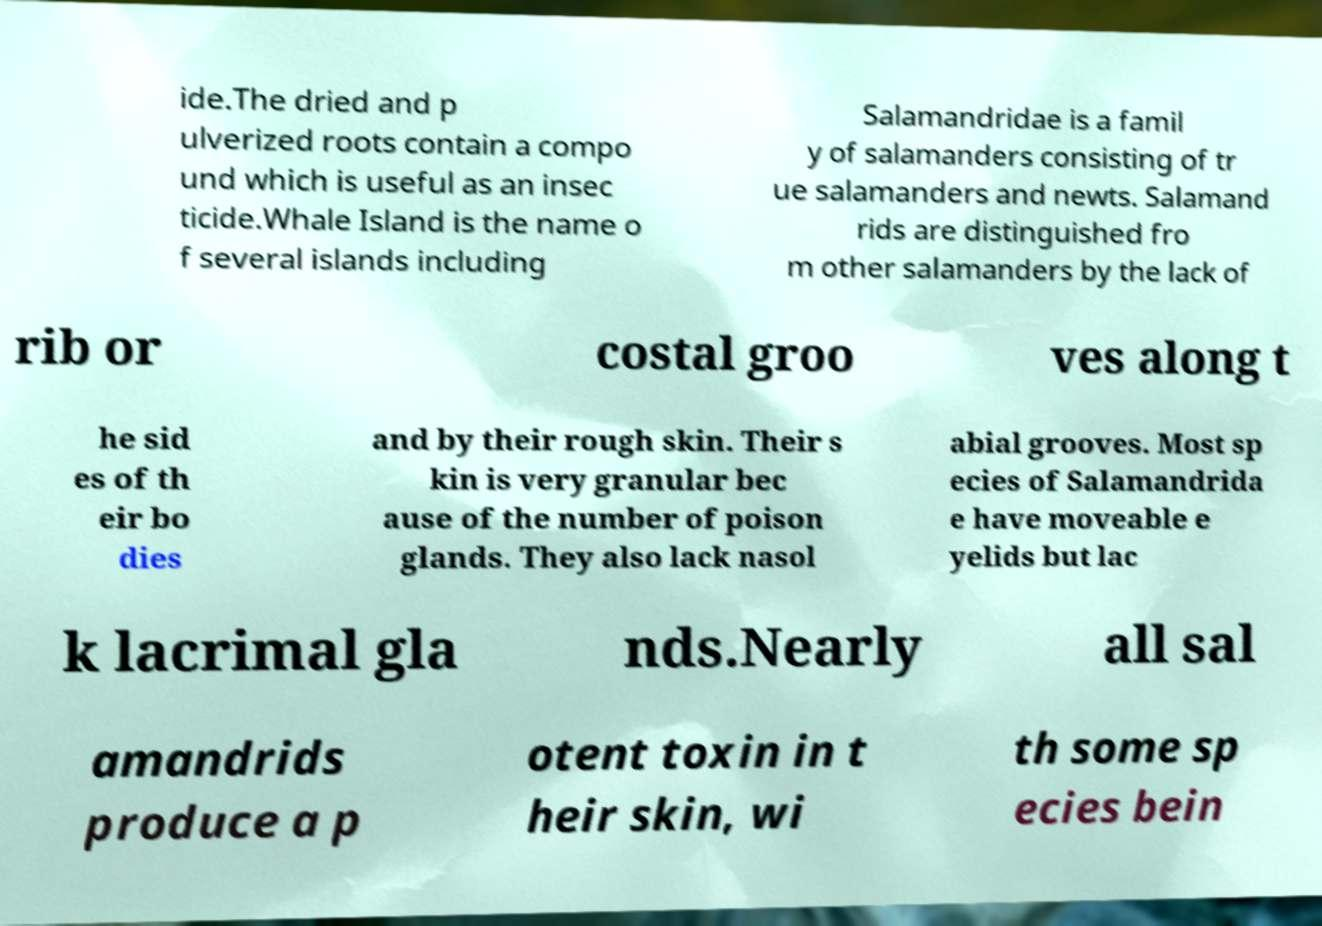For documentation purposes, I need the text within this image transcribed. Could you provide that? ide.The dried and p ulverized roots contain a compo und which is useful as an insec ticide.Whale Island is the name o f several islands including Salamandridae is a famil y of salamanders consisting of tr ue salamanders and newts. Salamand rids are distinguished fro m other salamanders by the lack of rib or costal groo ves along t he sid es of th eir bo dies and by their rough skin. Their s kin is very granular bec ause of the number of poison glands. They also lack nasol abial grooves. Most sp ecies of Salamandrida e have moveable e yelids but lac k lacrimal gla nds.Nearly all sal amandrids produce a p otent toxin in t heir skin, wi th some sp ecies bein 